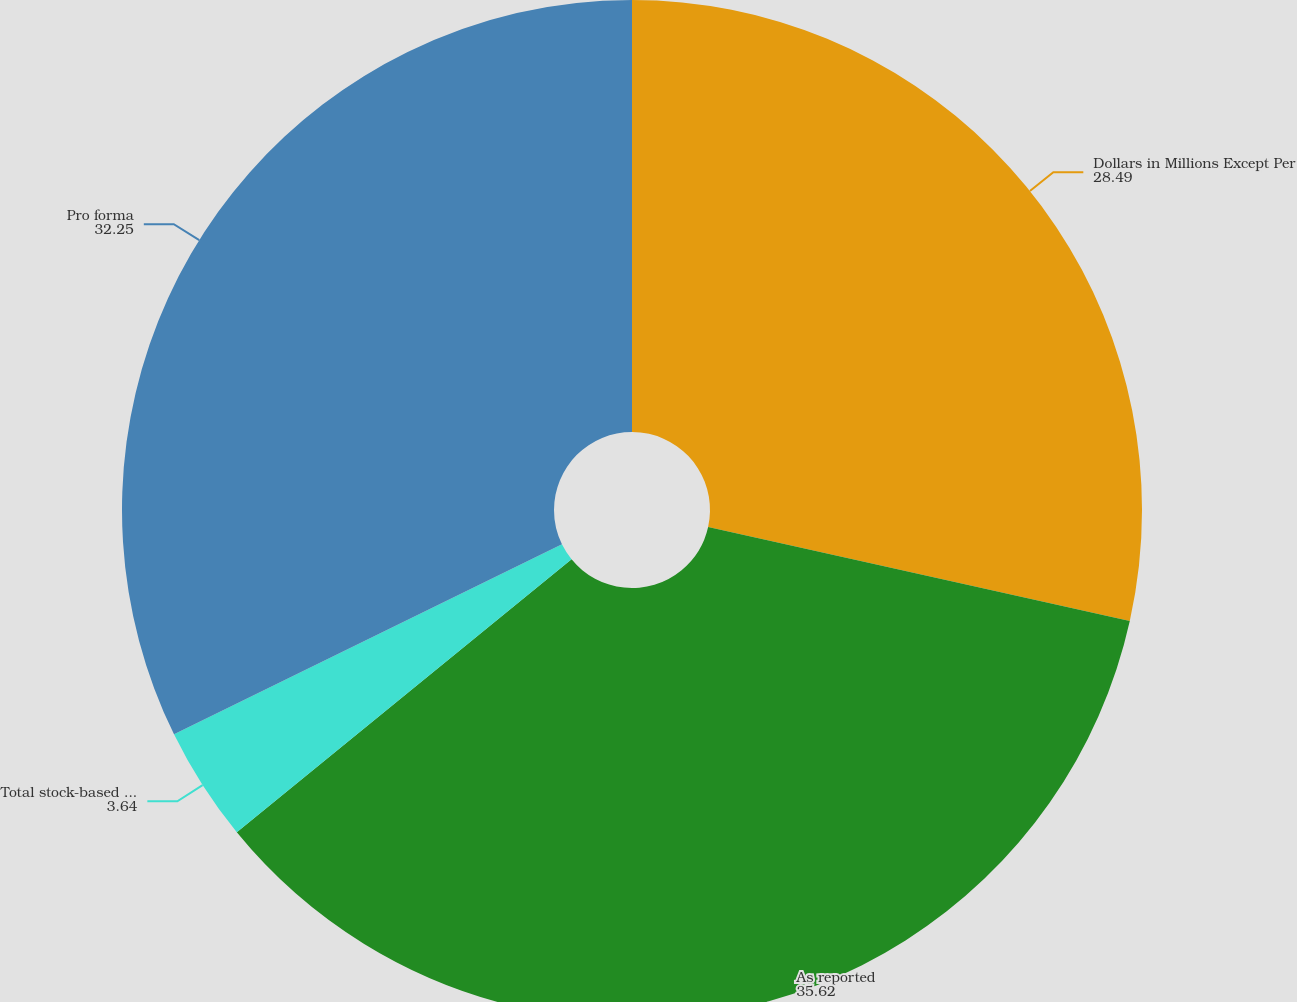Convert chart to OTSL. <chart><loc_0><loc_0><loc_500><loc_500><pie_chart><fcel>Dollars in Millions Except Per<fcel>As reported<fcel>Total stock-based employee<fcel>Pro forma<nl><fcel>28.49%<fcel>35.62%<fcel>3.64%<fcel>32.25%<nl></chart> 